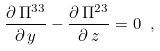<formula> <loc_0><loc_0><loc_500><loc_500>\frac { \partial \, \Pi ^ { 3 3 } } { \partial \, y } - \frac { \partial \, \Pi ^ { 2 3 } } { \partial \, z } = 0 \ ,</formula> 